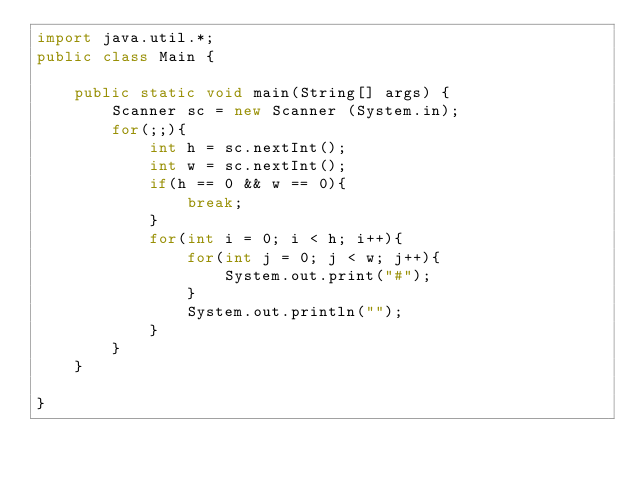Convert code to text. <code><loc_0><loc_0><loc_500><loc_500><_Java_>import java.util.*;
public class Main {

	public static void main(String[] args) {
		Scanner sc = new Scanner (System.in);
		for(;;){
			int h = sc.nextInt();
			int w = sc.nextInt();
			if(h == 0 && w == 0){
				break;
			}
			for(int i = 0; i < h; i++){
				for(int j = 0; j < w; j++){
					System.out.print("#");
				}
				System.out.println("");
			}
		}
	}

}</code> 